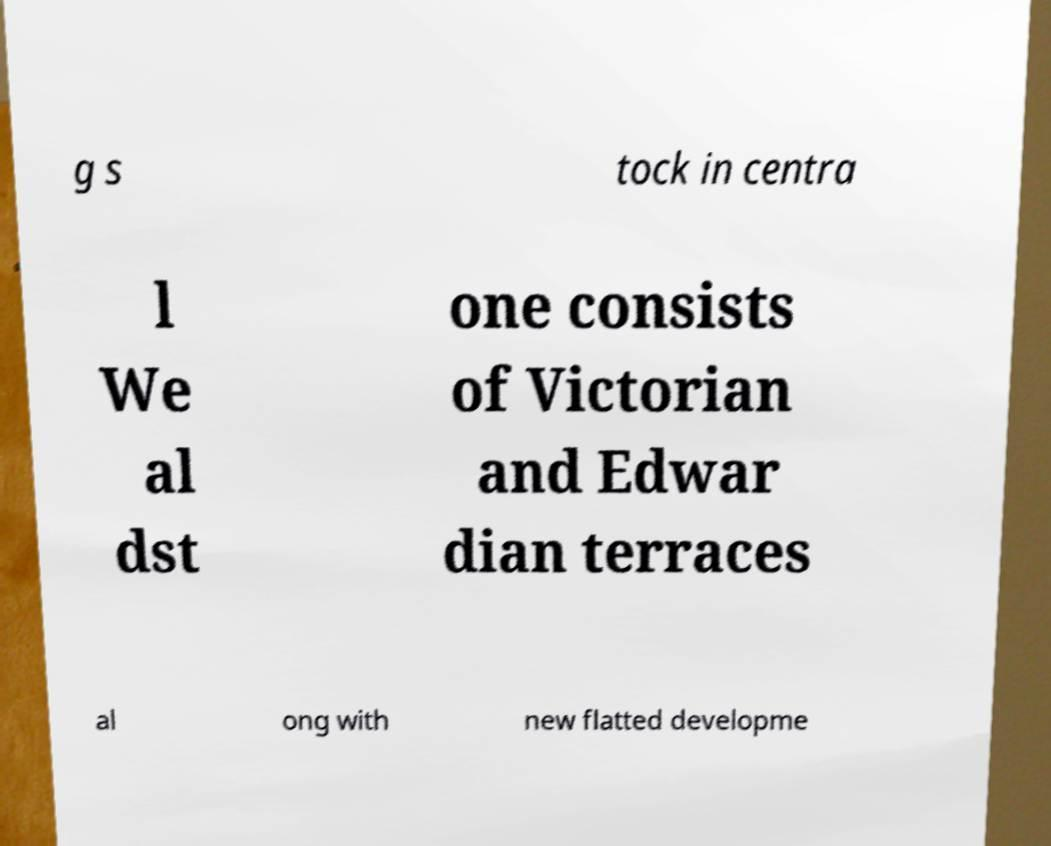Could you extract and type out the text from this image? g s tock in centra l We al dst one consists of Victorian and Edwar dian terraces al ong with new flatted developme 